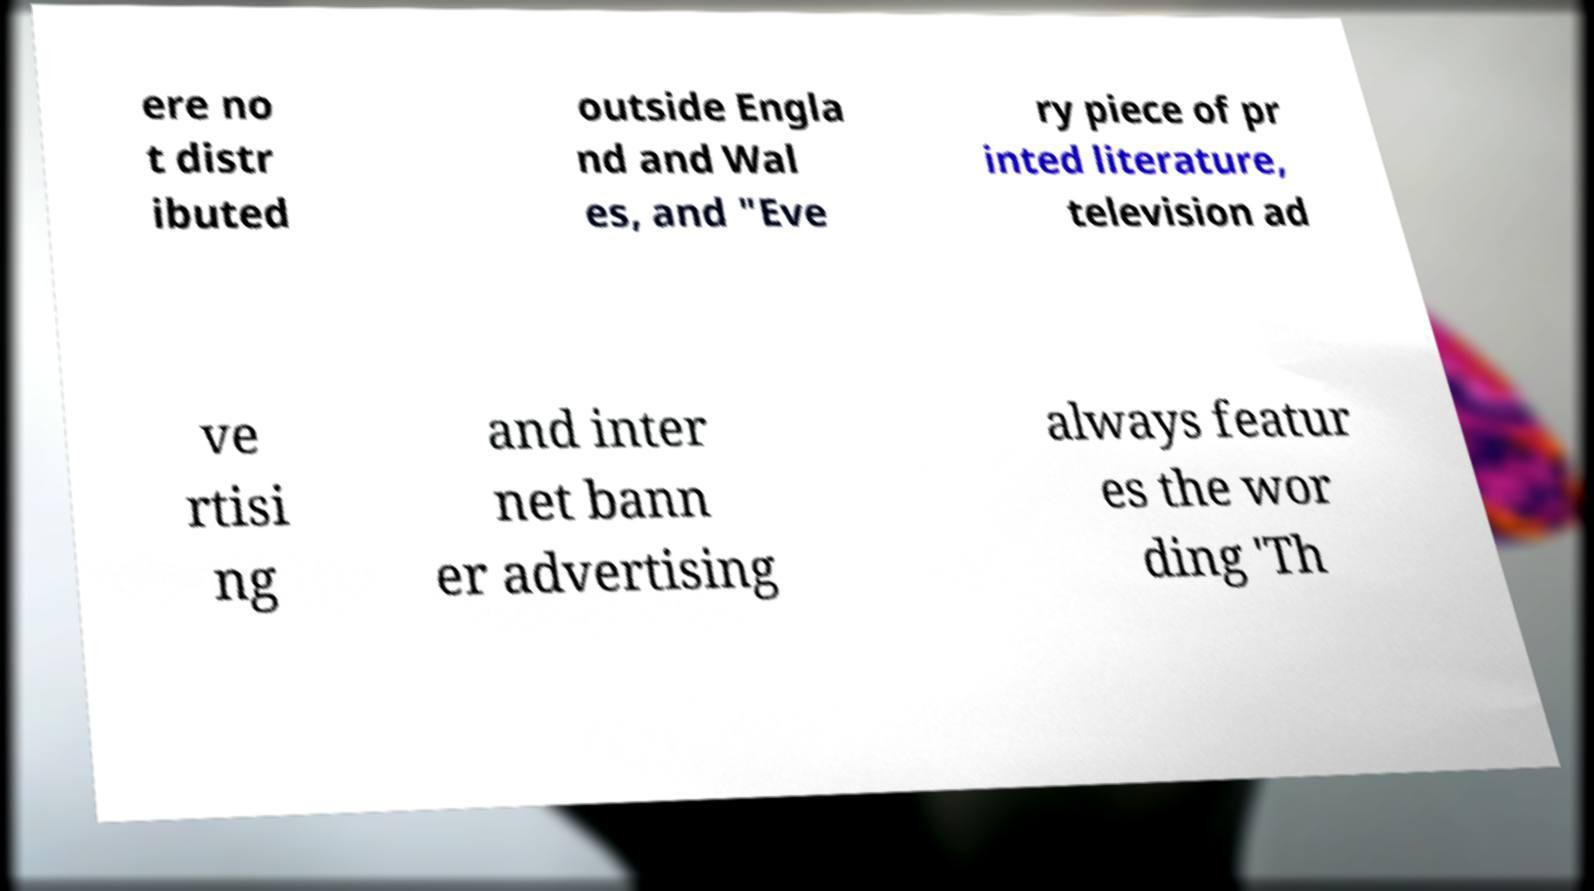Could you assist in decoding the text presented in this image and type it out clearly? ere no t distr ibuted outside Engla nd and Wal es, and "Eve ry piece of pr inted literature, television ad ve rtisi ng and inter net bann er advertising always featur es the wor ding 'Th 